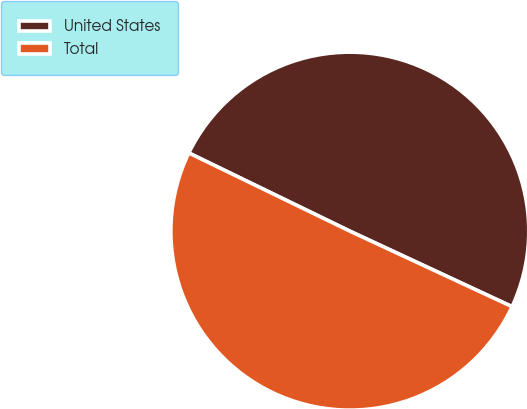<chart> <loc_0><loc_0><loc_500><loc_500><pie_chart><fcel>United States<fcel>Total<nl><fcel>49.74%<fcel>50.26%<nl></chart> 